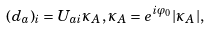<formula> <loc_0><loc_0><loc_500><loc_500>( { d } _ { a } ) _ { i } = U _ { a i } \kappa _ { A } , \kappa _ { A } = e ^ { i \varphi _ { 0 } } | \kappa _ { A } | ,</formula> 